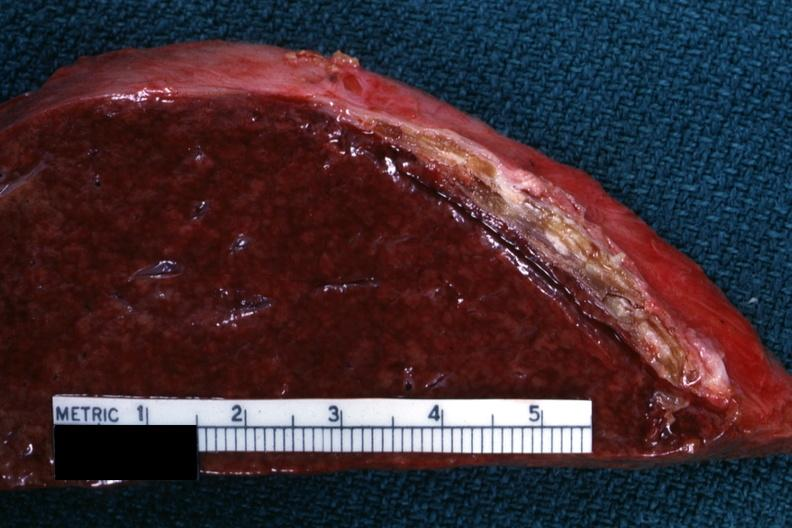does this image show cut surface showing very thickened capsule with focal calcification very good close-up photo?
Answer the question using a single word or phrase. Yes 